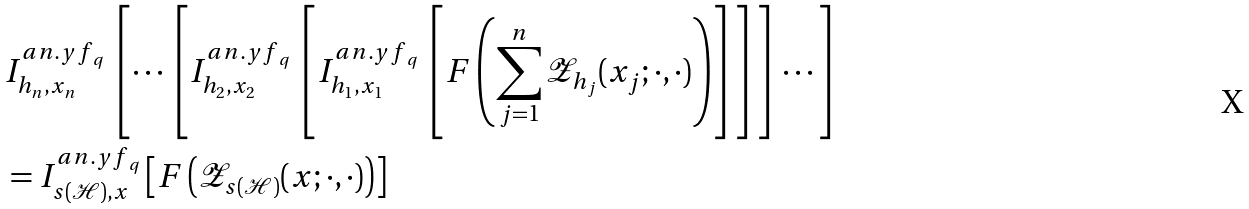<formula> <loc_0><loc_0><loc_500><loc_500>& I _ { h _ { n } , x _ { n } } ^ { a n . { y f } _ { q } } \left [ \cdots \left [ I _ { h _ { 2 } , x _ { 2 } } ^ { a n . { y f } _ { q } } \left [ I _ { h _ { 1 } , x _ { 1 } } ^ { a n . { y f } _ { q } } \left [ F \left ( \sum _ { j = 1 } ^ { n } \mathcal { Z } _ { h _ { j } } ( x _ { j } ; \cdot , \cdot ) \right ) \right ] \right ] \right ] \cdots \right ] \\ & = I _ { s ( \mathcal { H } ) , x } ^ { a n . { y f } _ { q } } \left [ F \left ( \mathcal { Z } _ { s ( \mathcal { H } ) } ( x ; \cdot , \cdot ) \right ) \right ]</formula> 